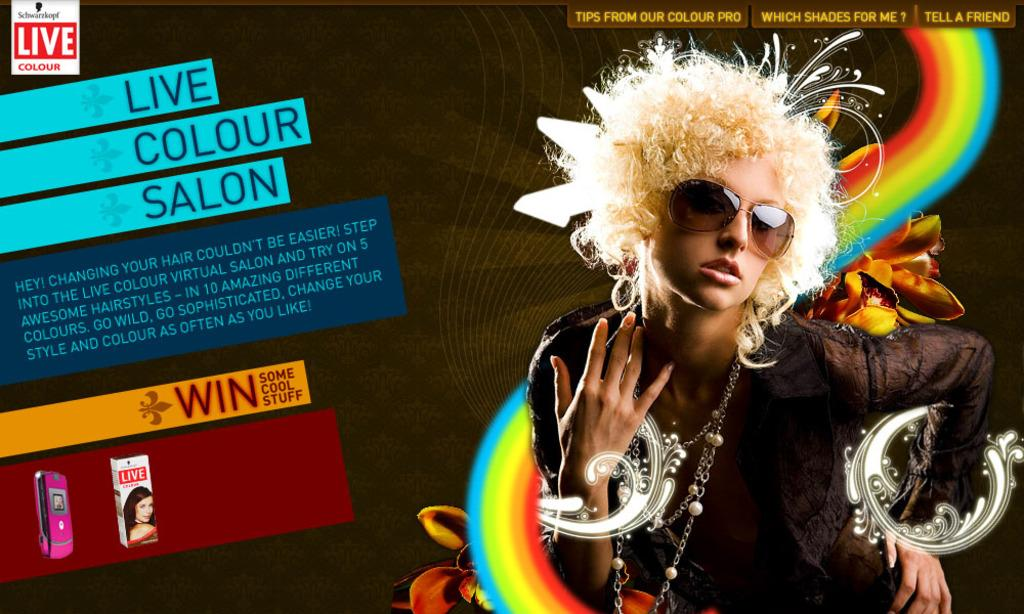What can be seen in the image? There is a person in the image. What else is present in the image besides the person? There is text in the image. Can you describe the person's appearance? The person is wearing clothes and sunglasses. What type of hospital can be seen in the image? There is no hospital present in the image. Are there any boats visible in the image? There are no boats present in the image. 